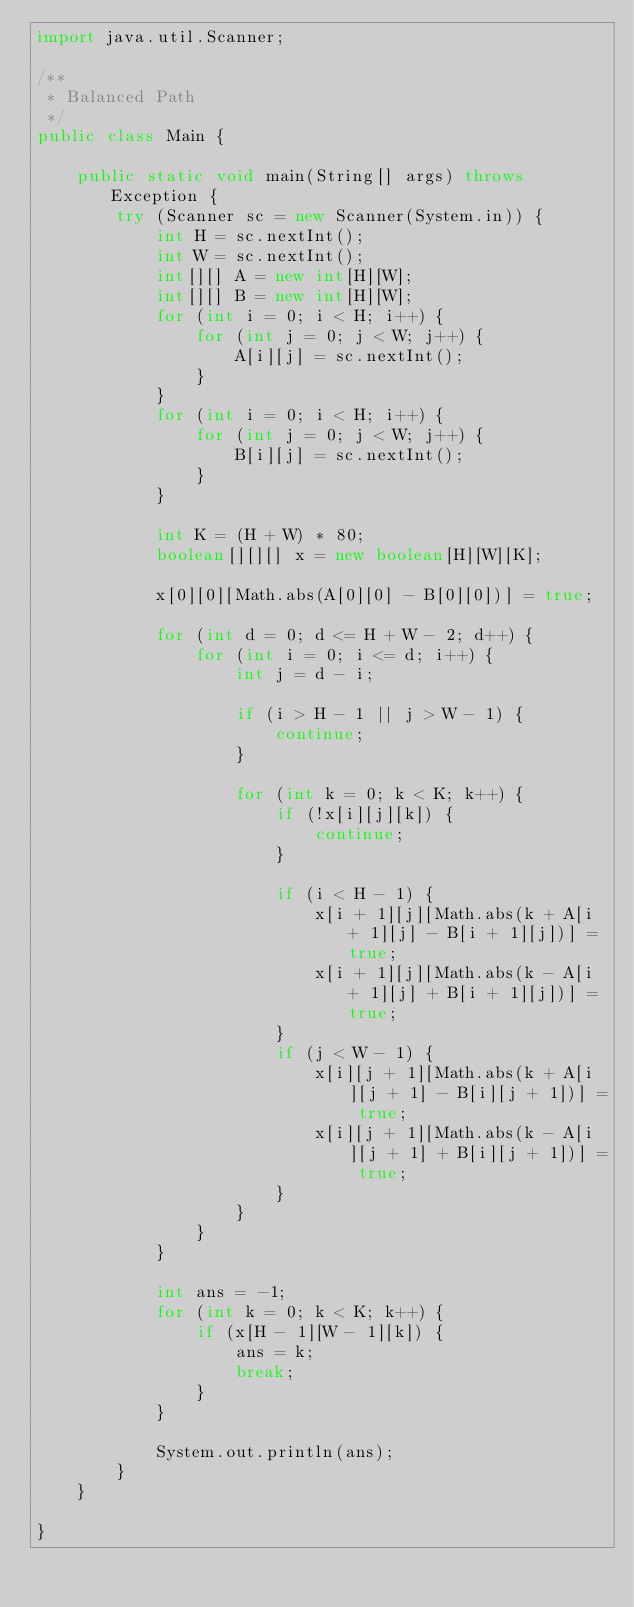<code> <loc_0><loc_0><loc_500><loc_500><_Java_>import java.util.Scanner;

/**
 * Balanced Path
 */
public class Main {

    public static void main(String[] args) throws Exception {
        try (Scanner sc = new Scanner(System.in)) {
            int H = sc.nextInt();
            int W = sc.nextInt();
            int[][] A = new int[H][W];
            int[][] B = new int[H][W];
            for (int i = 0; i < H; i++) {
                for (int j = 0; j < W; j++) {
                    A[i][j] = sc.nextInt();
                }
            }
            for (int i = 0; i < H; i++) {
                for (int j = 0; j < W; j++) {
                    B[i][j] = sc.nextInt();
                }
            }

            int K = (H + W) * 80;
            boolean[][][] x = new boolean[H][W][K];

            x[0][0][Math.abs(A[0][0] - B[0][0])] = true;

            for (int d = 0; d <= H + W - 2; d++) {
                for (int i = 0; i <= d; i++) {
                    int j = d - i;

                    if (i > H - 1 || j > W - 1) {
                        continue;
                    }

                    for (int k = 0; k < K; k++) {
                        if (!x[i][j][k]) {
                            continue;
                        }

                        if (i < H - 1) {
                            x[i + 1][j][Math.abs(k + A[i + 1][j] - B[i + 1][j])] = true;
                            x[i + 1][j][Math.abs(k - A[i + 1][j] + B[i + 1][j])] = true;
                        }
                        if (j < W - 1) {
                            x[i][j + 1][Math.abs(k + A[i][j + 1] - B[i][j + 1])] = true;
                            x[i][j + 1][Math.abs(k - A[i][j + 1] + B[i][j + 1])] = true;
                        }
                    }
                }
            }

            int ans = -1;
            for (int k = 0; k < K; k++) {
                if (x[H - 1][W - 1][k]) {
                    ans = k;
                    break;
                }
            }

            System.out.println(ans);
        }
    }

}
</code> 